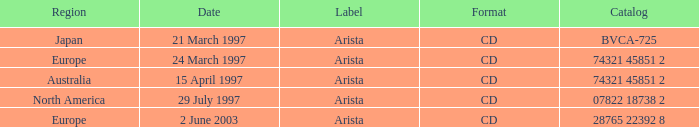What Label has the Region of Australia? Arista. 